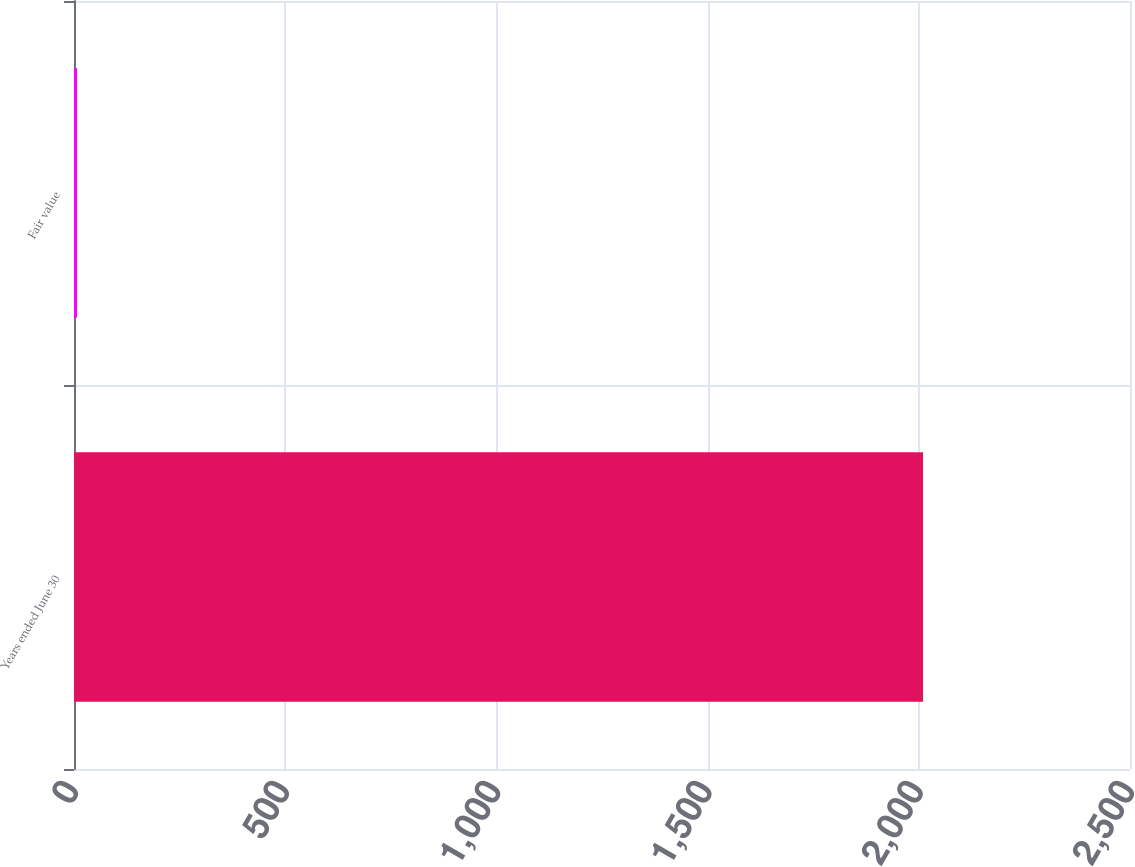Convert chart to OTSL. <chart><loc_0><loc_0><loc_500><loc_500><bar_chart><fcel>Years ended June 30<fcel>Fair value<nl><fcel>2010<fcel>7.05<nl></chart> 